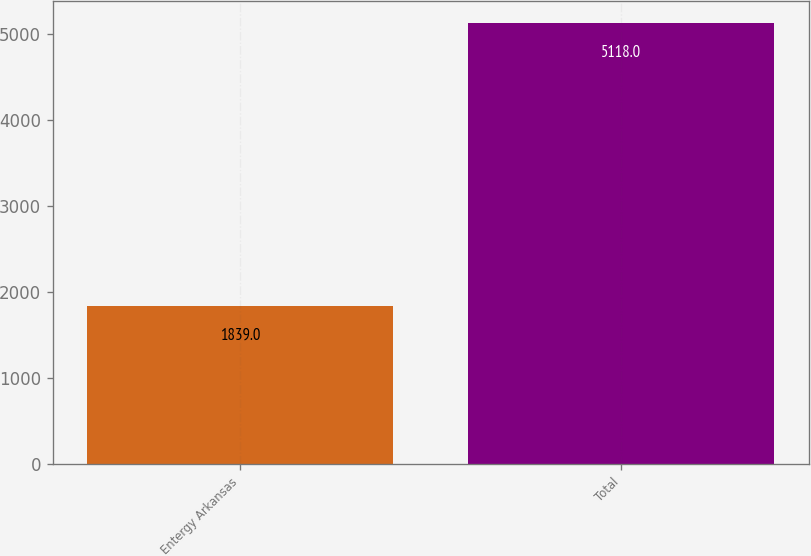<chart> <loc_0><loc_0><loc_500><loc_500><bar_chart><fcel>Entergy Arkansas<fcel>Total<nl><fcel>1839<fcel>5118<nl></chart> 